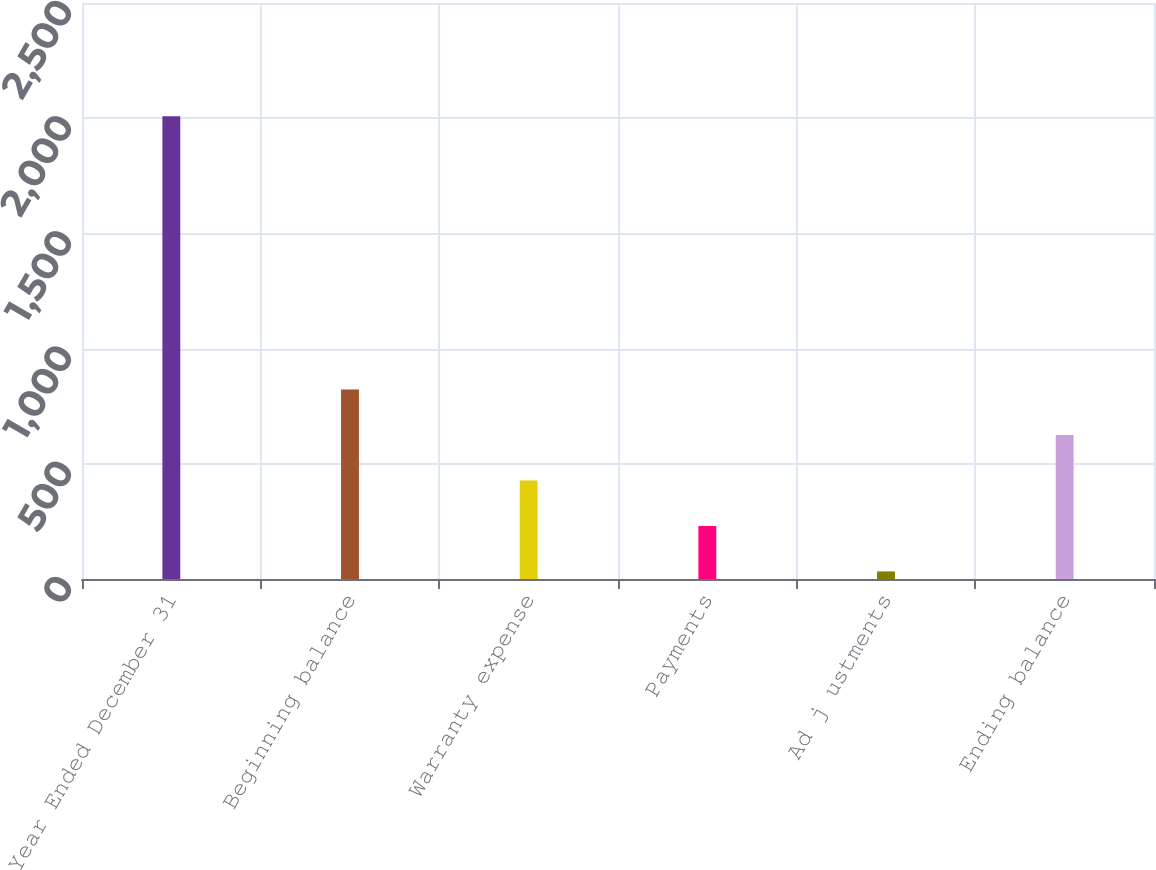Convert chart to OTSL. <chart><loc_0><loc_0><loc_500><loc_500><bar_chart><fcel>Year Ended December 31<fcel>Beginning balance<fcel>Warranty expense<fcel>Payments<fcel>Ad j ustments<fcel>Ending balance<nl><fcel>2008<fcel>823<fcel>428<fcel>230.5<fcel>33<fcel>625.5<nl></chart> 